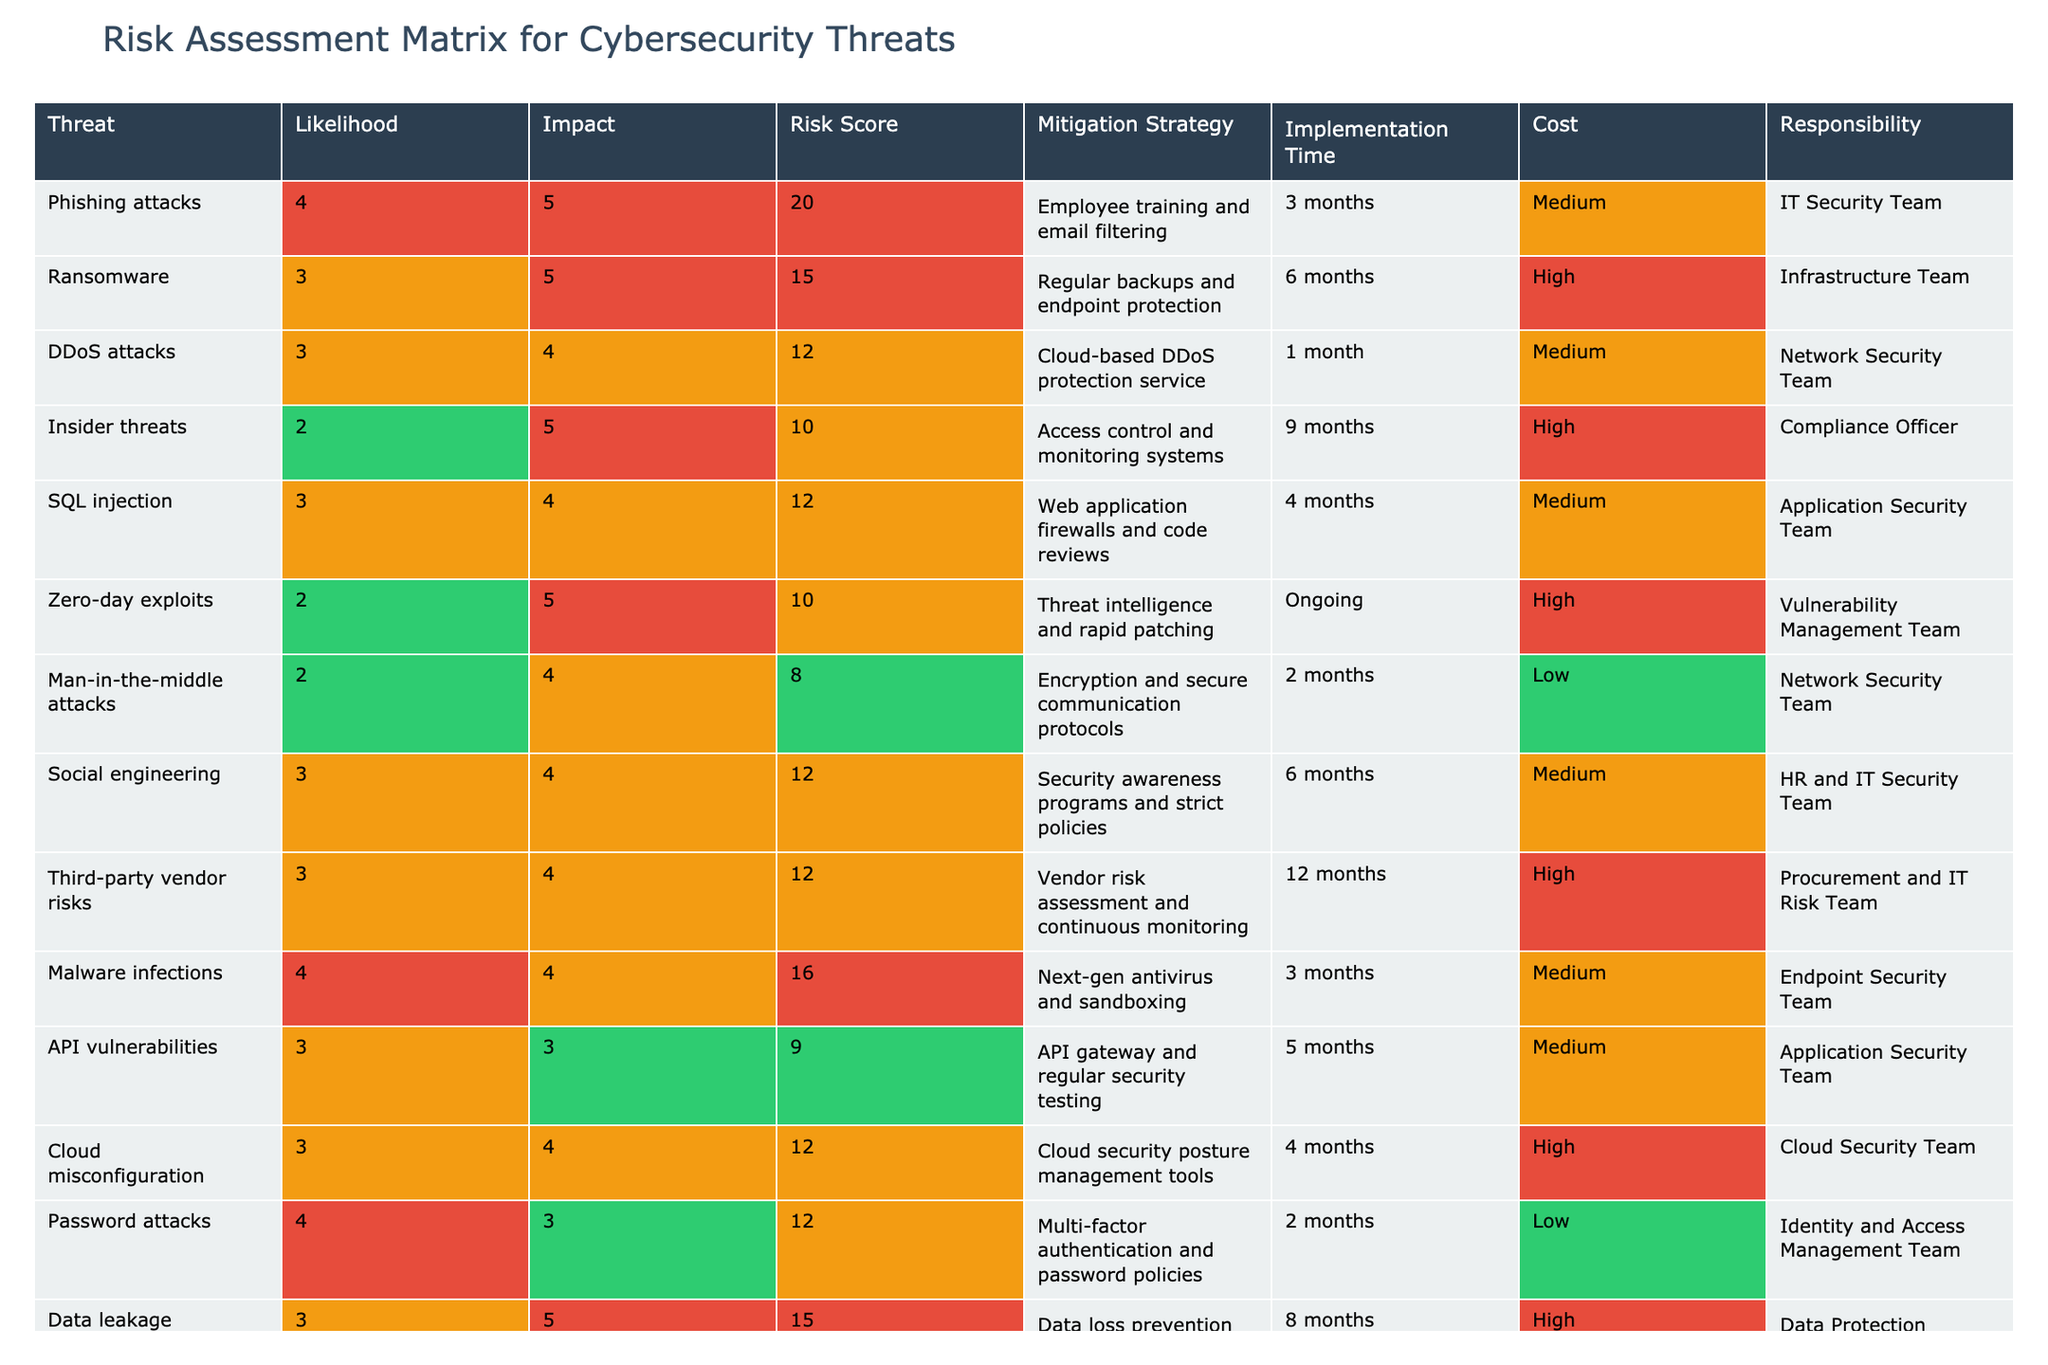What is the highest risk score in the table? By looking at the table, the highest risk score is 20, which corresponds to phishing attacks.
Answer: 20 How many threats have a mitigation strategy that includes employee training? There is only one threat, phishing attacks, that has a mitigation strategy involving employee training.
Answer: 1 What is the average likelihood score of all threats listed? Adding the likelihood scores (4 + 3 + 3 + 2 + 3 + 2 + 2 + 3 + 3 + 4 + 4 + 3 + 3 + 2) gives 43. There are 14 threats, so the average is 43/14 ≈ 3.07.
Answer: 3.07 Is the implementation time for cloud misconfiguration longer than that for ransomware? The implementation time for cloud misconfiguration is 4 months, whereas ransomware is 6 months. Hence, it is not longer.
Answer: No Which team is responsible for the mitigation strategy of malware infections? According to the table, the Endpoint Security Team is responsible for mitigating malware infections.
Answer: Endpoint Security Team How many threats have a cost categorized as 'High'? By looking at the table, there are 6 threats listed with a cost of 'High', specifically ransomware, insider threats, zero-day exploits, third-party vendor risks, data leakage, and cloud misconfiguration.
Answer: 6 What percentage of the threats have an impact score of 5? There are 5 threats with an impact score of 5 (phishing attacks, ransomware, insider threats, zero-day exploits, and data leakage). The percentage is (5/14) * 100 = approximately 35.71%.
Answer: 35.71% Are there any threats with a likelihood score below 3? Reviewing the table shows that only the insider threats and man-in-the-middle attacks have a likelihood score below 3.
Answer: Yes What is the risk score for social engineering, and which team is responsible for it? The risk score for social engineering is 12, and the responsible teams are HR and IT Security.
Answer: 12, HR and IT Security Team If we combine the risk scores of all threats assigned to the IT Security Team, what would be the total? The risk scores assigned to the IT Security Team are 20 (phishing attacks), 12 (social engineering), and 16 (malware infections), which sums up to 48.
Answer: 48 